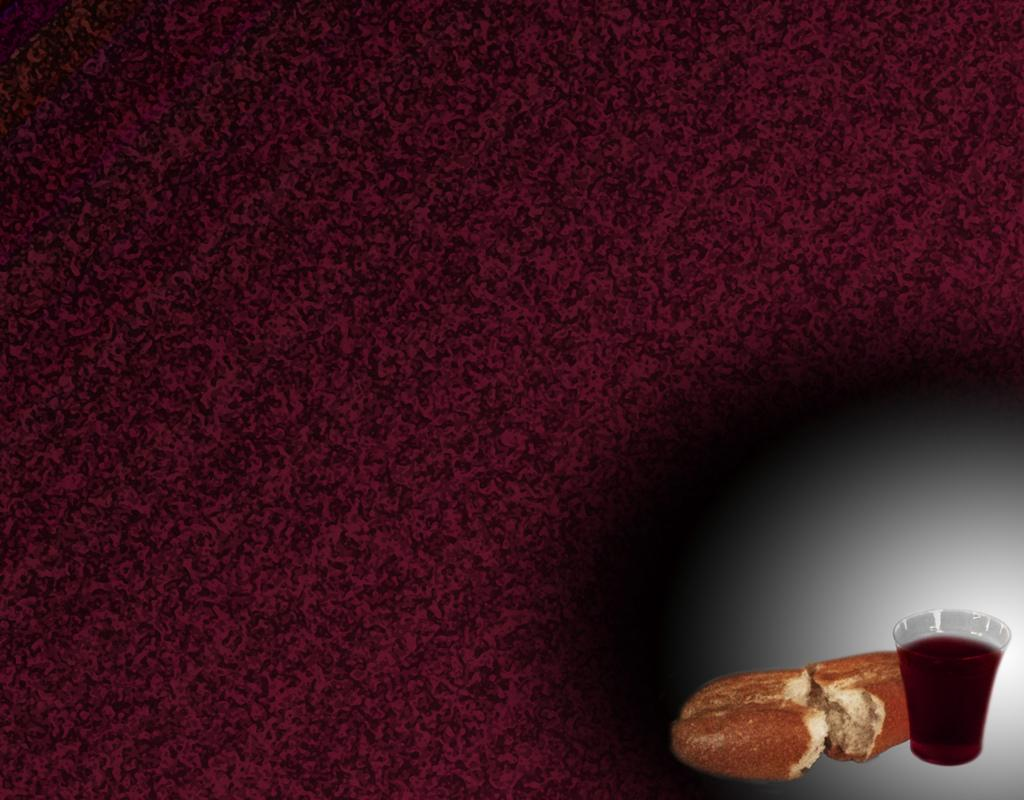What type of food is visible in the image? There is food in the image, but the specific type is not mentioned in the facts. What is in the glass that is visible in the image? There is a drink in the glass that is visible in the image. Where is the glass located in the image? The glass is in the bottom right side of the image. What color dominates the remaining part of the image? The remaining part of the image has a purple color. What type of structure can be seen in the image? There is no structure present in the image; it primarily features food, a glass with a drink, and a purple background. Can you see any bones in the image? There are no bones visible in the image. 